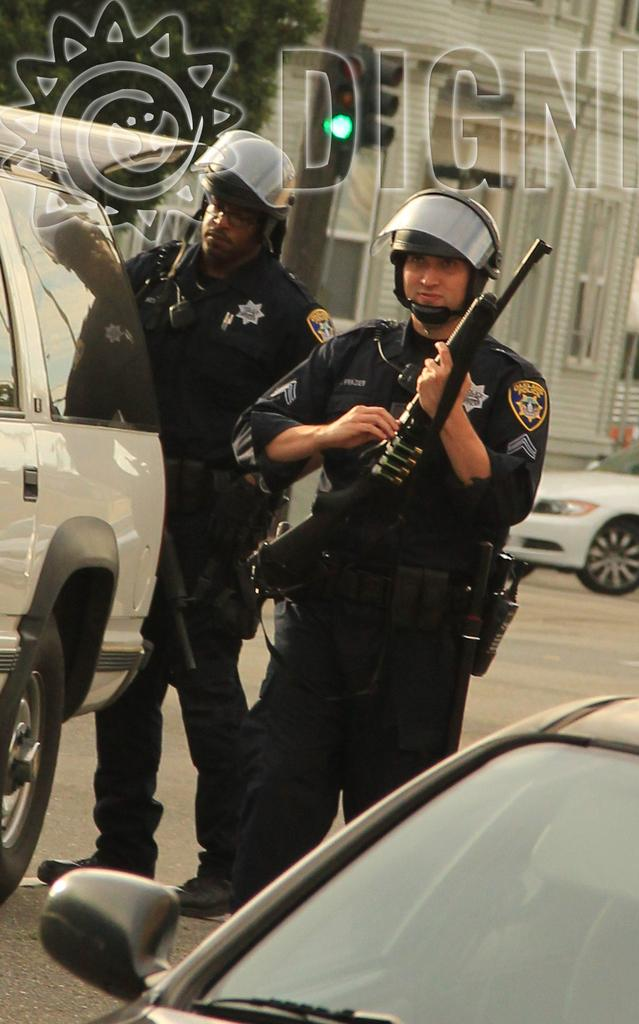What can be seen on the road in the image? There are cars on the road in the image. Are there any people on the road? Yes, there are two men on the road. What is one of the men holding? One of the men is holding a gun. What can be seen in the background of the image? There is a building, trees, a pole, and a traffic signal in the background. Where is the camera located in the image? There is no camera present in the image. What type of crook is the man with the gun trying to steal? There is no crook or theft depicted in the image; it only shows a man holding a gun and cars on the road. 